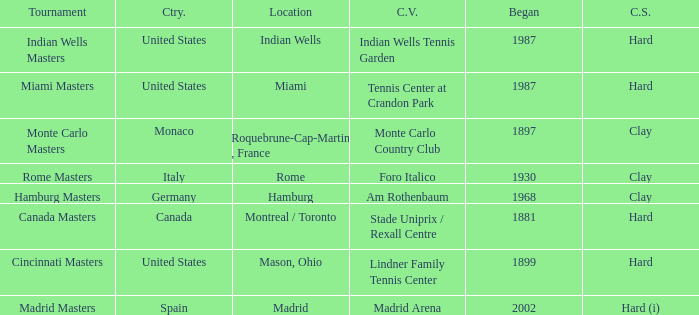What is the current venue for the Miami Masters tournament? Tennis Center at Crandon Park. 